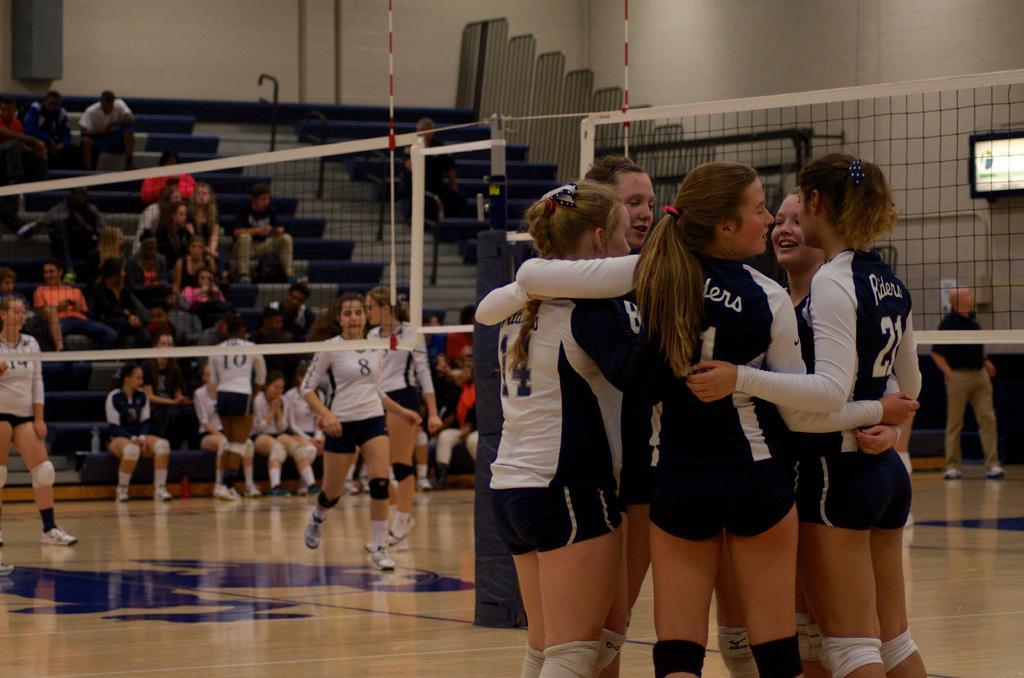Could you give a brief overview of what you see in this image? In this picture there are group of people standing. At the back there is a net and there is a screen on the wall and there is a railing. On the right side of the image there is a man walking. On the left side of the image there are group of people sitting and there are group of people running and there is an object on the wall and there is a railing on the staircase. At the bottom there is a floor. 